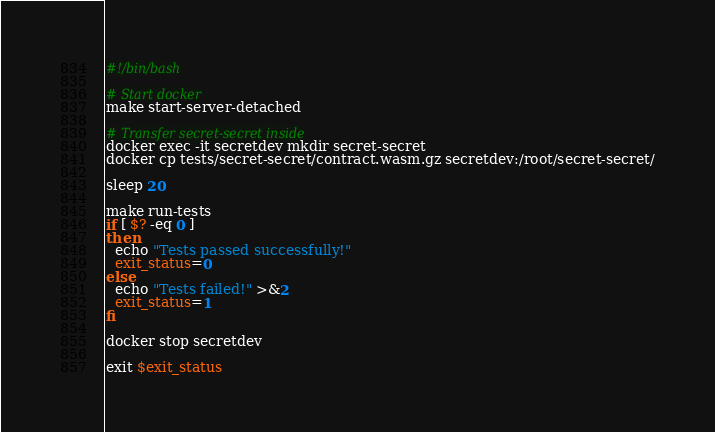Convert code to text. <code><loc_0><loc_0><loc_500><loc_500><_Bash_>#!/bin/bash

# Start docker
make start-server-detached

# Transfer secret-secret inside
docker exec -it secretdev mkdir secret-secret
docker cp tests/secret-secret/contract.wasm.gz secretdev:/root/secret-secret/

sleep 20

make run-tests
if [ $? -eq 0 ]
then
  echo "Tests passed successfully!"
  exit_status=0
else
  echo "Tests failed!" >&2
  exit_status=1
fi

docker stop secretdev

exit $exit_status</code> 